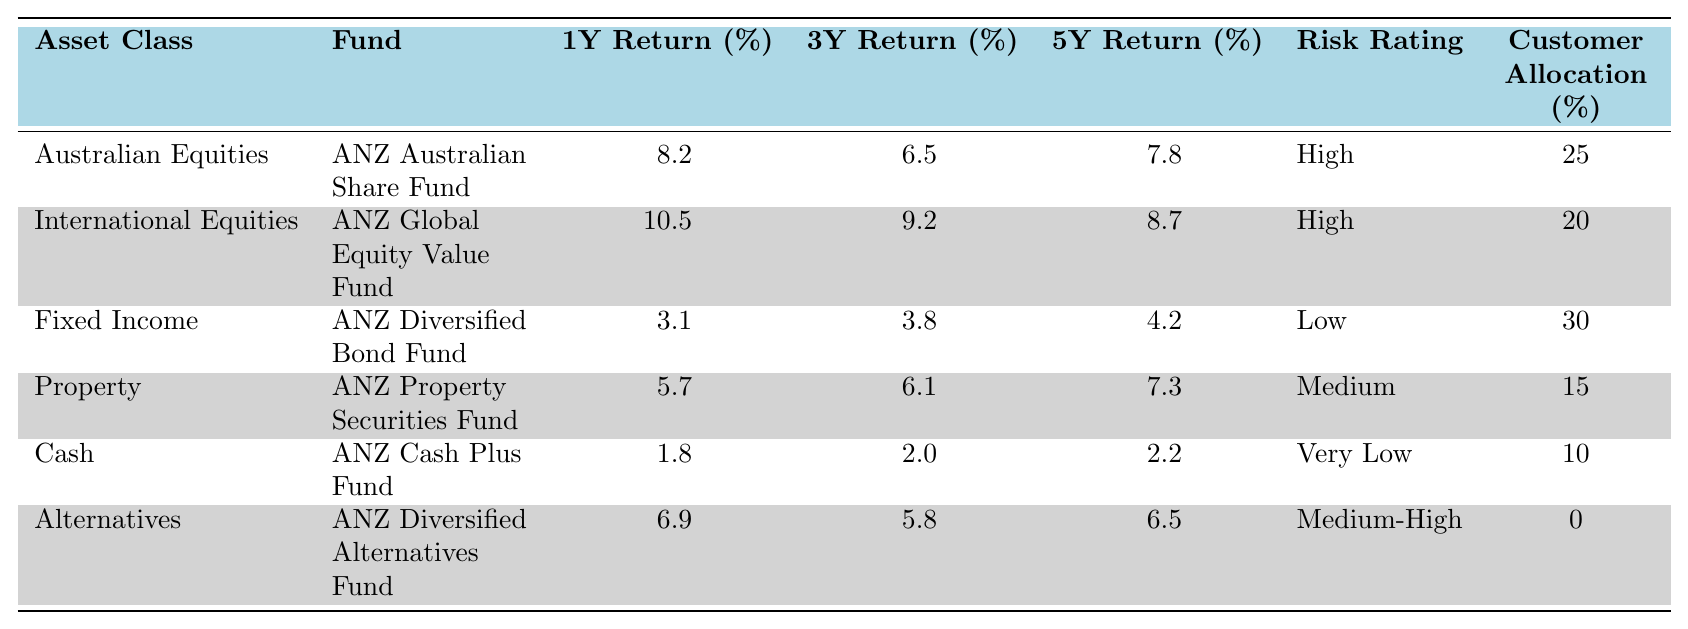What is the 1-year return for Australian Equities? The table shows that the 1-year return for Australian Equities is listed under the relevant row. It is 8.2%.
Answer: 8.2% Which fund has the highest 3-year return? Looking at the 3-year return column, the maximum value is 9.2%, which corresponds to the International Equities asset class.
Answer: ANZ Global Equity Value Fund Is the risk rating for Fixed Income low? The risk rating for the Fixed Income asset class is explicitly stated in the table as "Low".
Answer: Yes What is the total allocation percentage for Property and Cash combined? The allocation for Property is 15% and for Cash is 10%. Adding these two gives 15 + 10 = 25%.
Answer: 25% How does the 5-year return for Alternatives compare to that of Fixed Income? The 5-year return for Alternatives is 6.5%, while for Fixed Income it is 4.2%. Since 6.5% is greater than 4.2%, Alternatives has a higher return over 5 years.
Answer: Alternatives has a higher return Which asset class has the lowest 1-year return? By reviewing the 1-year return column, Cash has the lowest value at 1.8%.
Answer: Cash If a customer allocated 100% of their investment equally between the five asset classes, what would be the average 1-year return? The 1-year returns are 8.2, 10.5, 3.1, 5.7, and 1.8. Adding these gives a total of 29.3% and dividing by 5 results in an average of 29.3/5 = 5.86%.
Answer: 5.86% Is it true that the 5-year return for both Australian Equities and International Equities is above 7%? The 5-year return for Australian Equities is 7.8% and for International Equities is 8.7%. Both values are indeed above 7%.
Answer: Yes What is the difference in 1-year returns between International Equities and Fixed Income? The 1-year return for International Equities is 10.5% while Fixed Income is 3.1%. The difference is 10.5 - 3.1 = 7.4%.
Answer: 7.4% What is the total customer allocation across all asset classes? The customer allocations are 25%, 20%, 30%, 15%, 10%, and 0%, summing these values gives a total of 100%.
Answer: 100% 